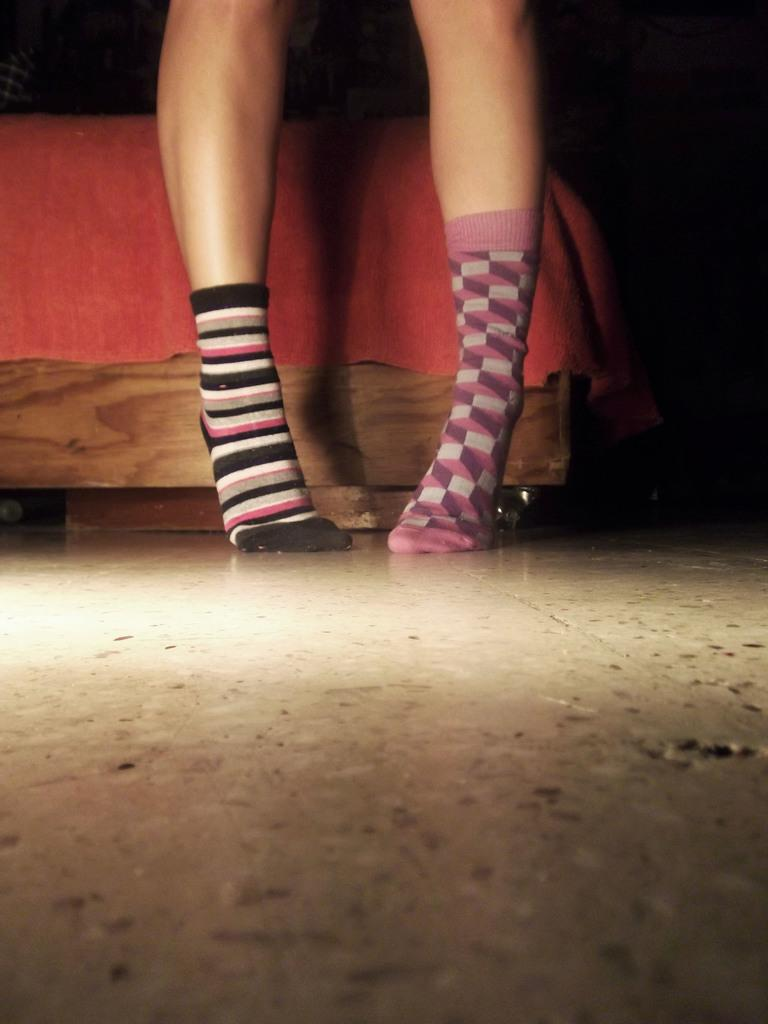What type of flooring is shown in the image? There are white color tiles in the image. What part of a person can be seen in the image? Human legs are visible in the image. What piece of furniture is present in the image? There is a bed in the image. What color is the cloth that can be seen in the image? There is a red color cloth in the image. Can you see any veins in the human legs in the image? The image does not show the veins in the human legs; it only shows the legs themselves. What type of crack is visible on the bed in the image? There is no crack visible on the bed in the image. 